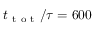<formula> <loc_0><loc_0><loc_500><loc_500>t _ { t o t } / \tau = 6 0 0</formula> 